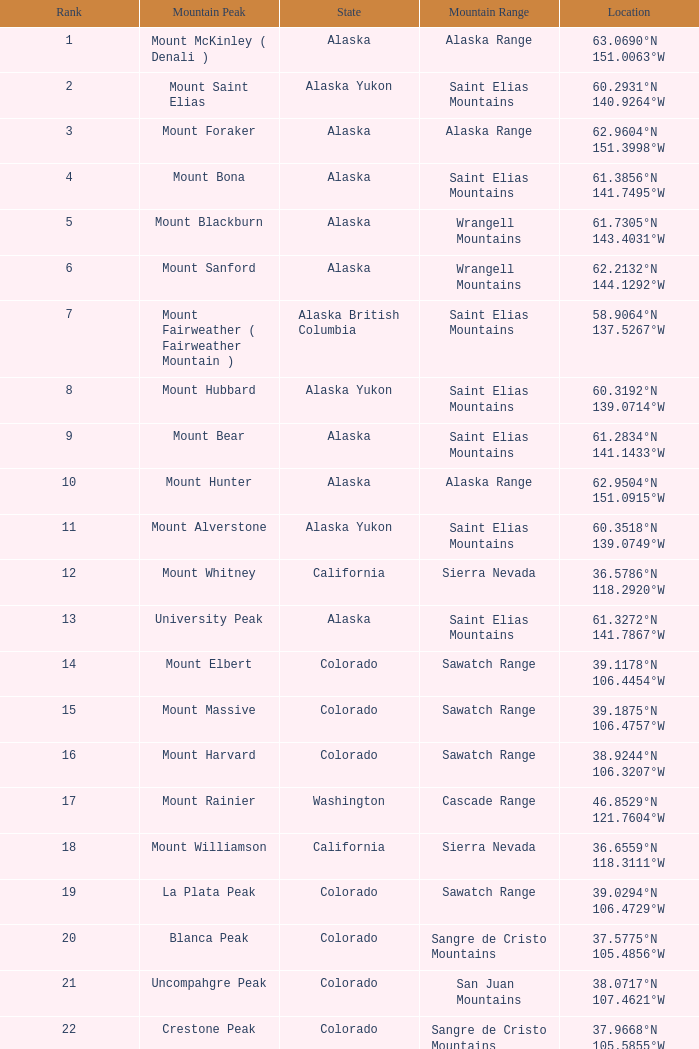What is the mountain range when the state is colorado, rank is higher than 90 and mountain peak is whetstone mountain? West Elk Mountains. 